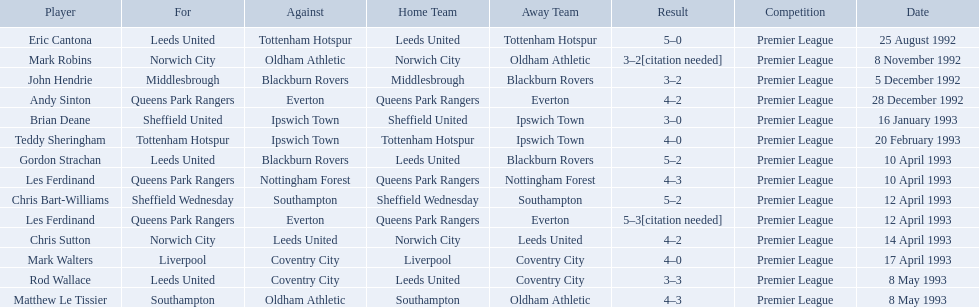Who are the players in 1992-93 fa premier league? Eric Cantona, Mark Robins, John Hendrie, Andy Sinton, Brian Deane, Teddy Sheringham, Gordon Strachan, Les Ferdinand, Chris Bart-Williams, Les Ferdinand, Chris Sutton, Mark Walters, Rod Wallace, Matthew Le Tissier. What is mark robins' result? 3–2[citation needed]. Which player has the same result? John Hendrie. 